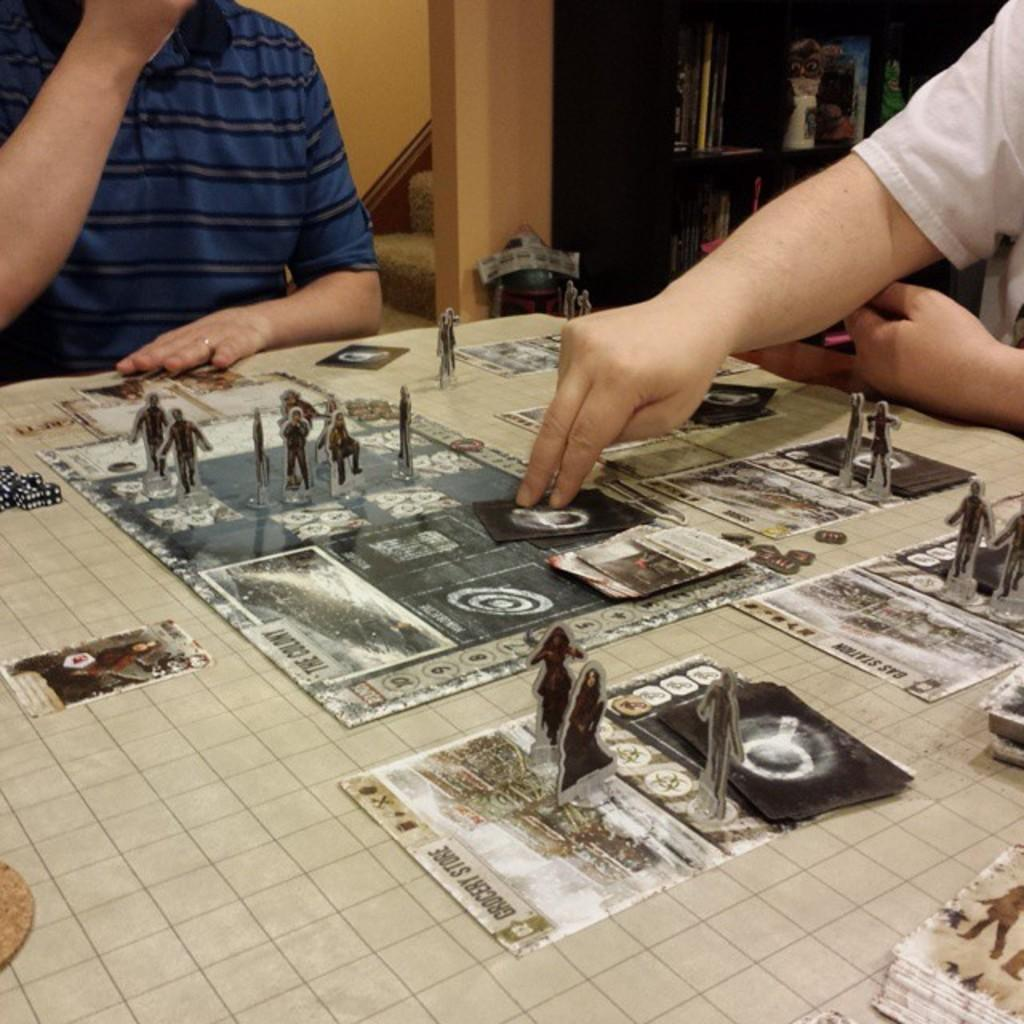How many people are present in the room? There are two people sitting in the room. What furniture is present in the room? There is a table in the room. What can be found on the table? There are objects on the table. What architectural features can be seen in the background? There is a cupboard, stairs, and a wall in the background. What type of legal advice is the toad providing to the people in the image? There is no toad present in the image, and therefore no legal advice can be provided. What type of engine is visible in the background of the image? There is no engine visible in the image; the background features a cupboard, stairs, and a wall. 